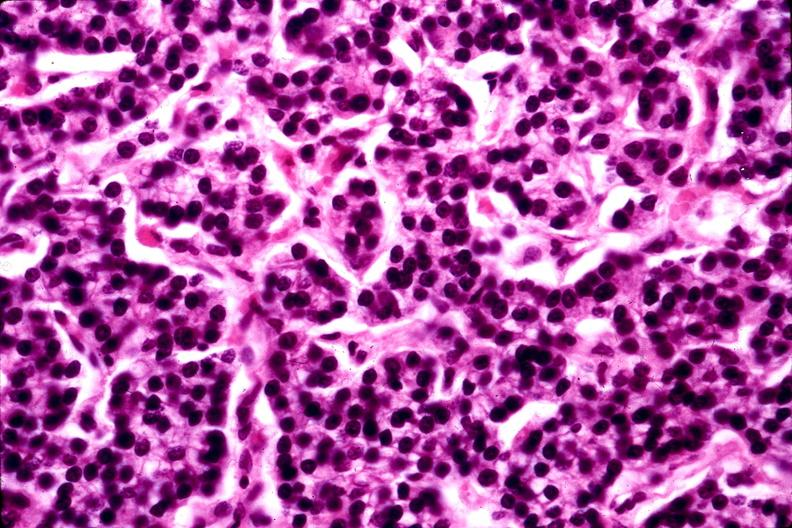s endocrine present?
Answer the question using a single word or phrase. Yes 